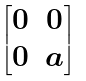Convert formula to latex. <formula><loc_0><loc_0><loc_500><loc_500>\begin{bmatrix} 0 & 0 \\ 0 & a \end{bmatrix}</formula> 